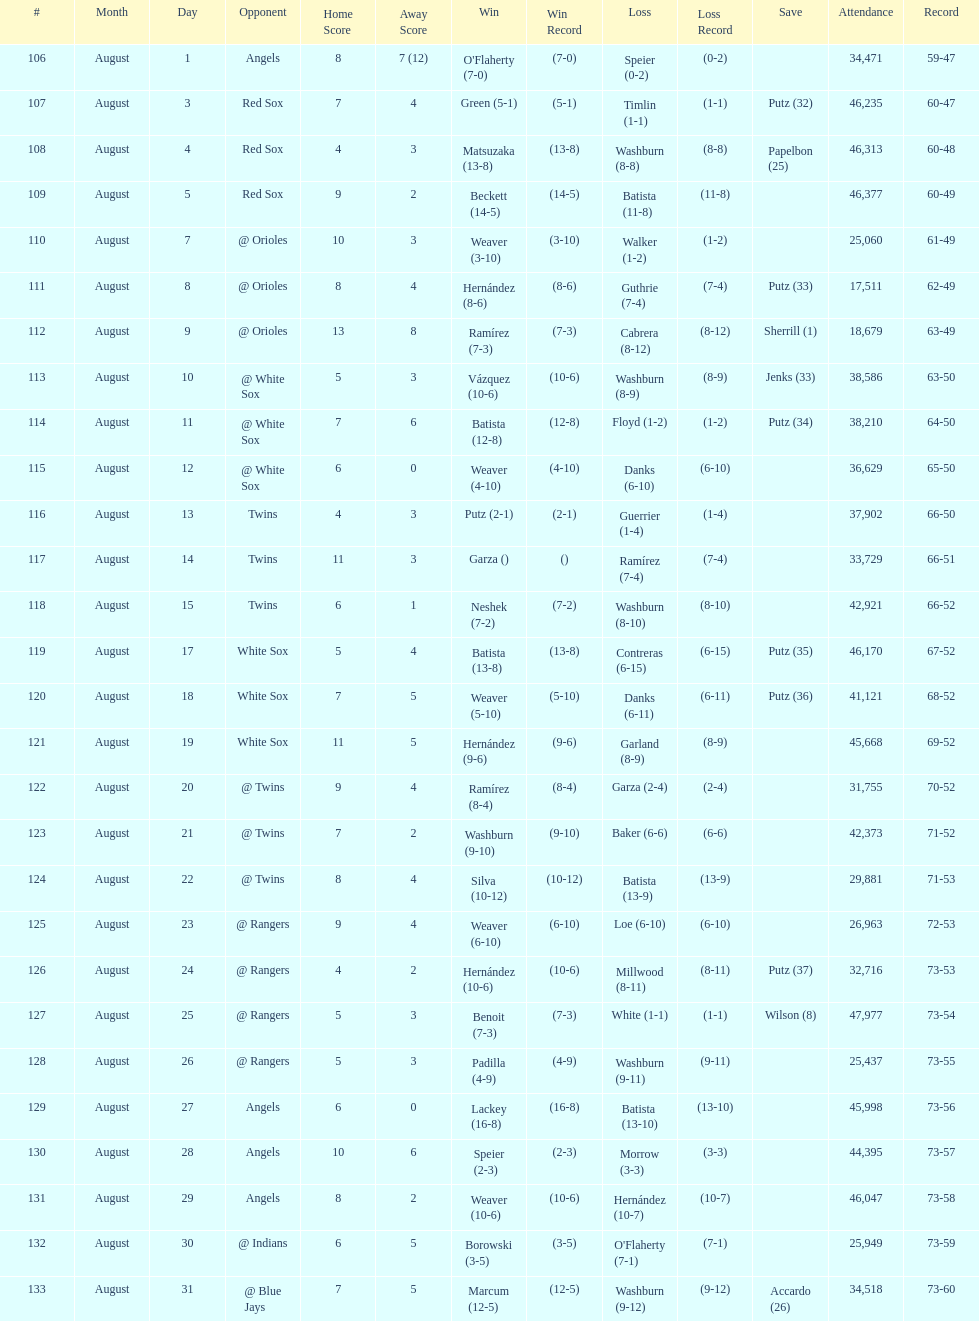What was the total number of games played in august 2007? 28. 